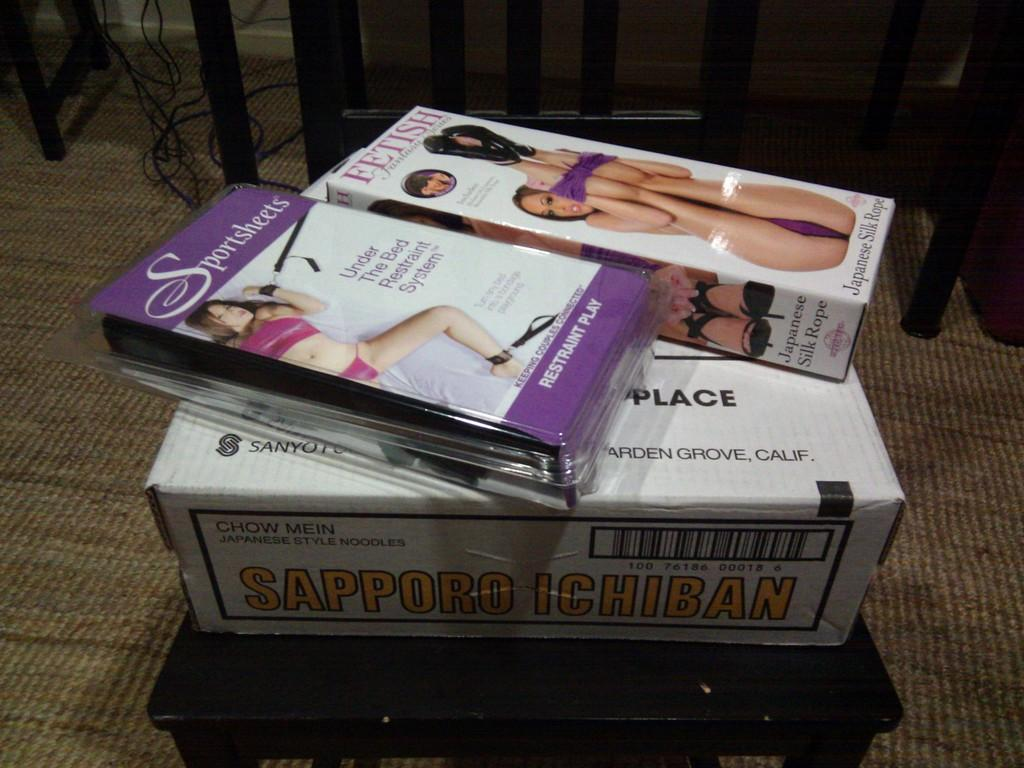<image>
Describe the image concisely. Two smaller boxes are sitting on a larger box of Sapporo Ichiban. 